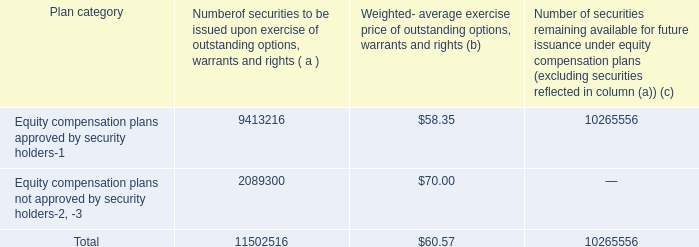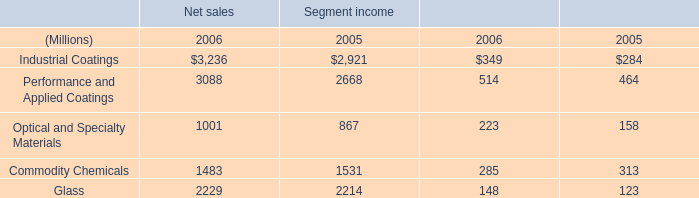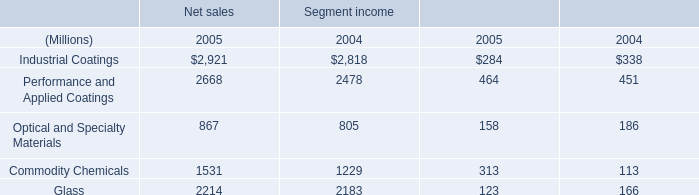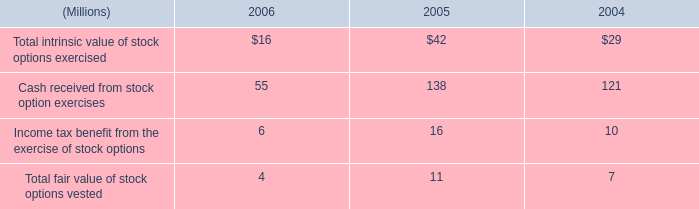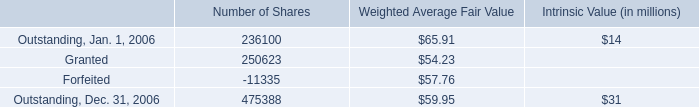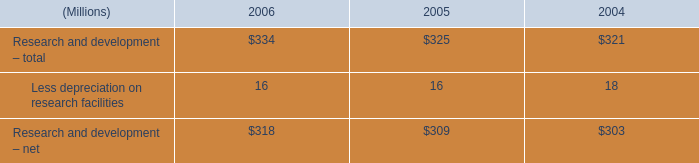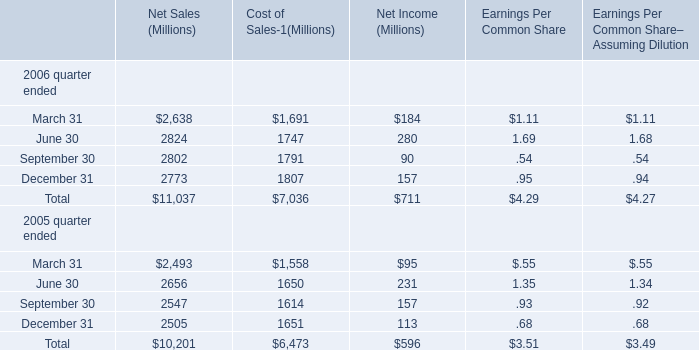what would net income have been for 2006 without the environmental remediation costs? 
Computations: ((711 + 106) * 1000000)
Answer: 817000000.0. 